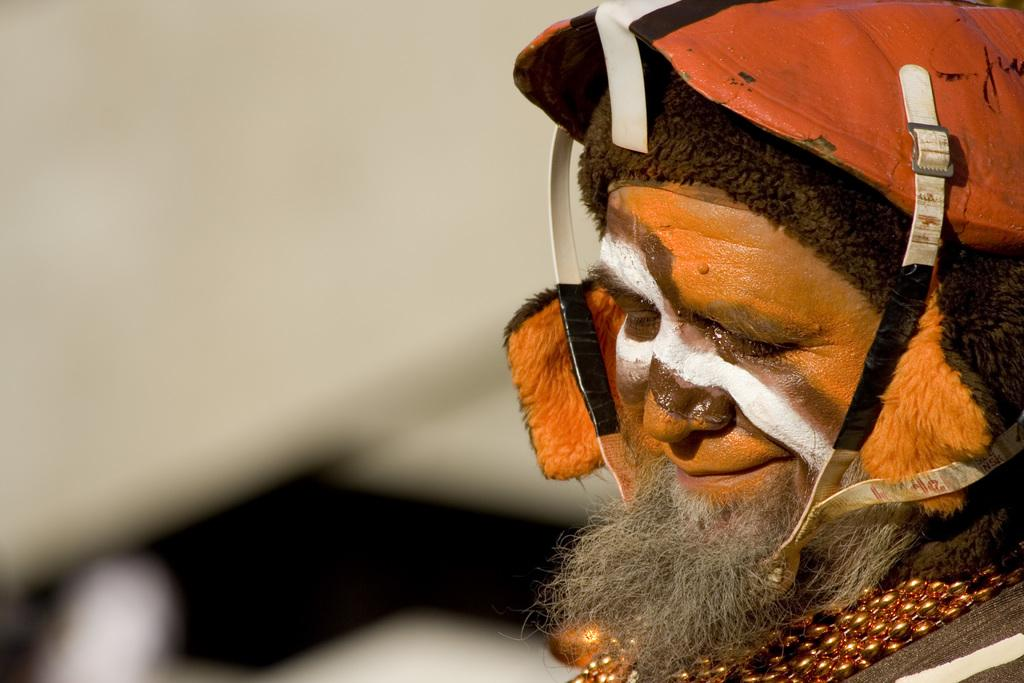What is the person on the right side of the image doing? The person is having bread. Can you describe the person's attire in the image? The person is wearing a cap. What can be observed about the background of the image? The background of the image is blurred. What type of expansion is the person experiencing in the image? There is no indication of any expansion in the image; it simply shows a person having bread while wearing a cap. Can you tell me who the person's manager is in the image? There is no information about a manager or any professional context in the image. 